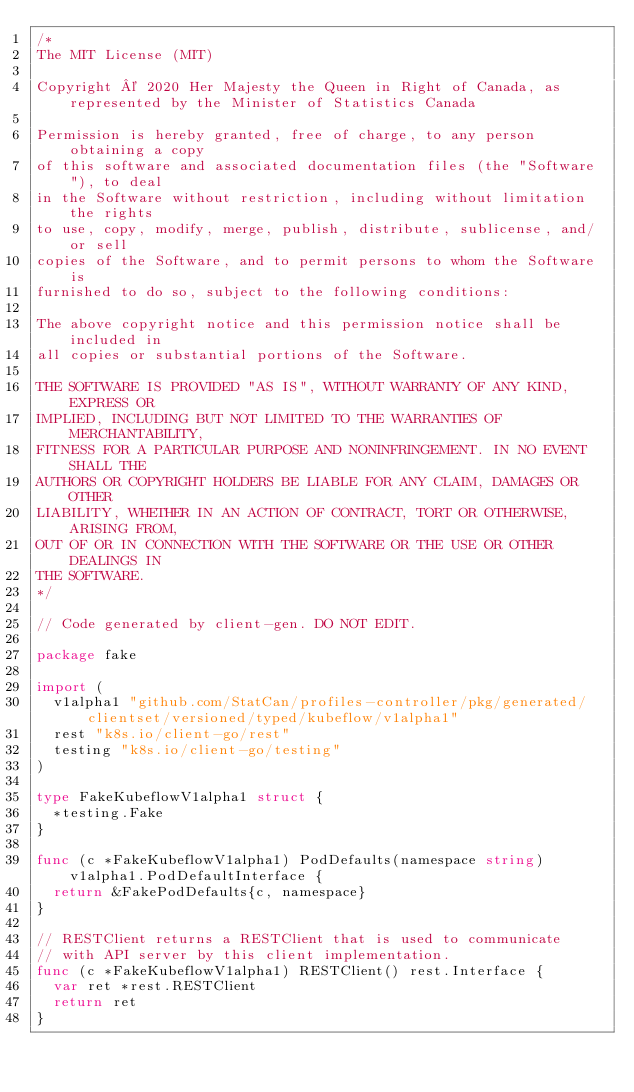Convert code to text. <code><loc_0><loc_0><loc_500><loc_500><_Go_>/*
The MIT License (MIT)

Copyright © 2020 Her Majesty the Queen in Right of Canada, as represented by the Minister of Statistics Canada

Permission is hereby granted, free of charge, to any person obtaining a copy
of this software and associated documentation files (the "Software"), to deal
in the Software without restriction, including without limitation the rights
to use, copy, modify, merge, publish, distribute, sublicense, and/or sell
copies of the Software, and to permit persons to whom the Software is
furnished to do so, subject to the following conditions:

The above copyright notice and this permission notice shall be included in
all copies or substantial portions of the Software.

THE SOFTWARE IS PROVIDED "AS IS", WITHOUT WARRANTY OF ANY KIND, EXPRESS OR
IMPLIED, INCLUDING BUT NOT LIMITED TO THE WARRANTIES OF MERCHANTABILITY,
FITNESS FOR A PARTICULAR PURPOSE AND NONINFRINGEMENT. IN NO EVENT SHALL THE
AUTHORS OR COPYRIGHT HOLDERS BE LIABLE FOR ANY CLAIM, DAMAGES OR OTHER
LIABILITY, WHETHER IN AN ACTION OF CONTRACT, TORT OR OTHERWISE, ARISING FROM,
OUT OF OR IN CONNECTION WITH THE SOFTWARE OR THE USE OR OTHER DEALINGS IN
THE SOFTWARE.
*/

// Code generated by client-gen. DO NOT EDIT.

package fake

import (
	v1alpha1 "github.com/StatCan/profiles-controller/pkg/generated/clientset/versioned/typed/kubeflow/v1alpha1"
	rest "k8s.io/client-go/rest"
	testing "k8s.io/client-go/testing"
)

type FakeKubeflowV1alpha1 struct {
	*testing.Fake
}

func (c *FakeKubeflowV1alpha1) PodDefaults(namespace string) v1alpha1.PodDefaultInterface {
	return &FakePodDefaults{c, namespace}
}

// RESTClient returns a RESTClient that is used to communicate
// with API server by this client implementation.
func (c *FakeKubeflowV1alpha1) RESTClient() rest.Interface {
	var ret *rest.RESTClient
	return ret
}
</code> 